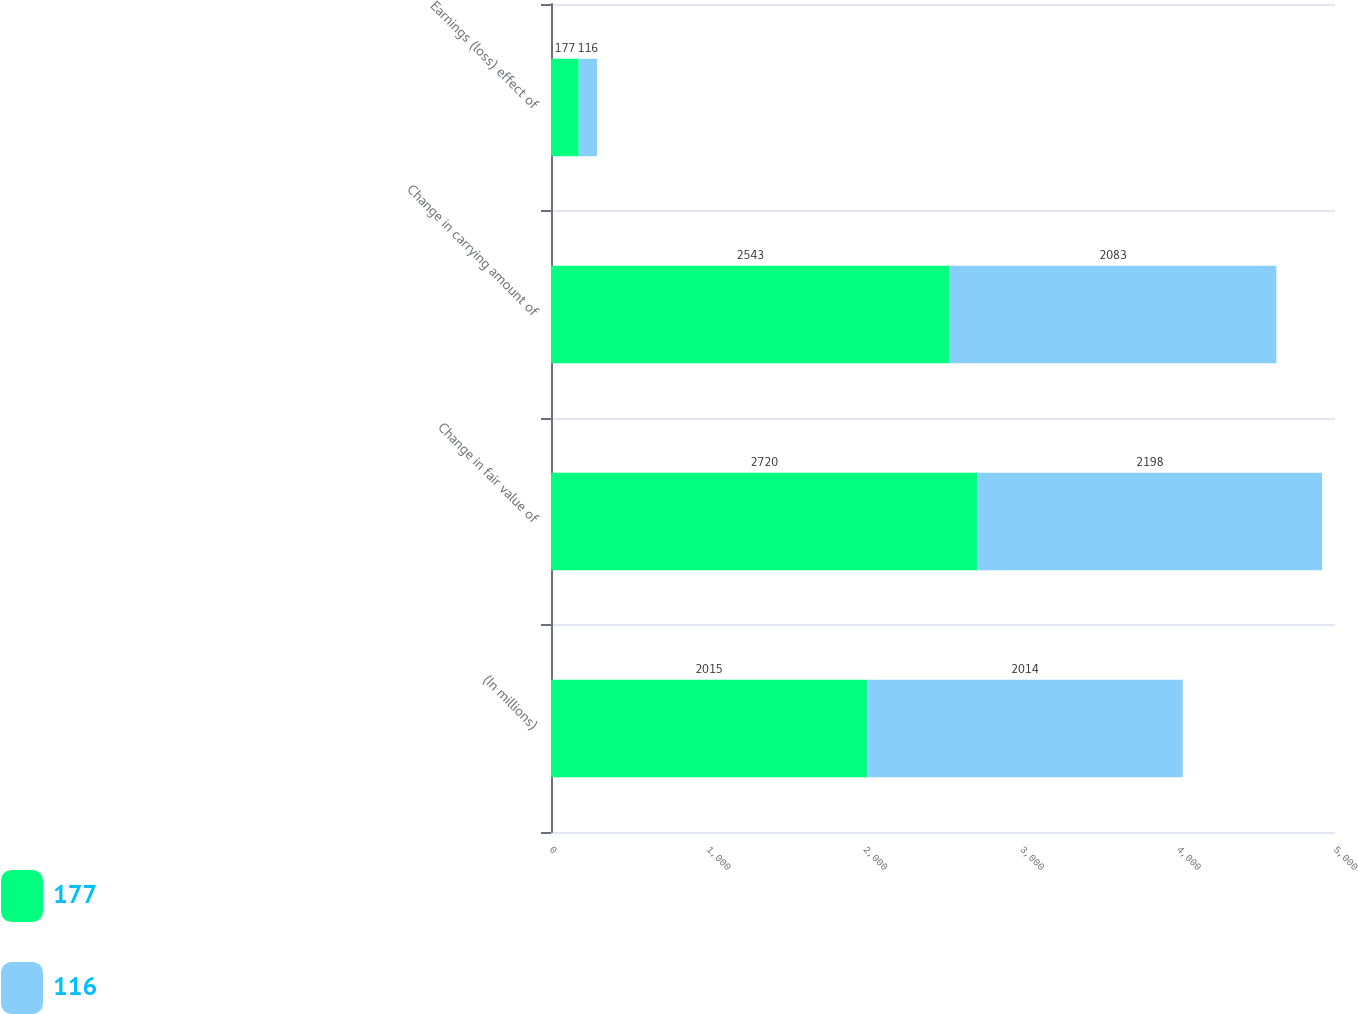<chart> <loc_0><loc_0><loc_500><loc_500><stacked_bar_chart><ecel><fcel>(In millions)<fcel>Change in fair value of<fcel>Change in carrying amount of<fcel>Earnings (loss) effect of<nl><fcel>177<fcel>2015<fcel>2720<fcel>2543<fcel>177<nl><fcel>116<fcel>2014<fcel>2198<fcel>2083<fcel>116<nl></chart> 